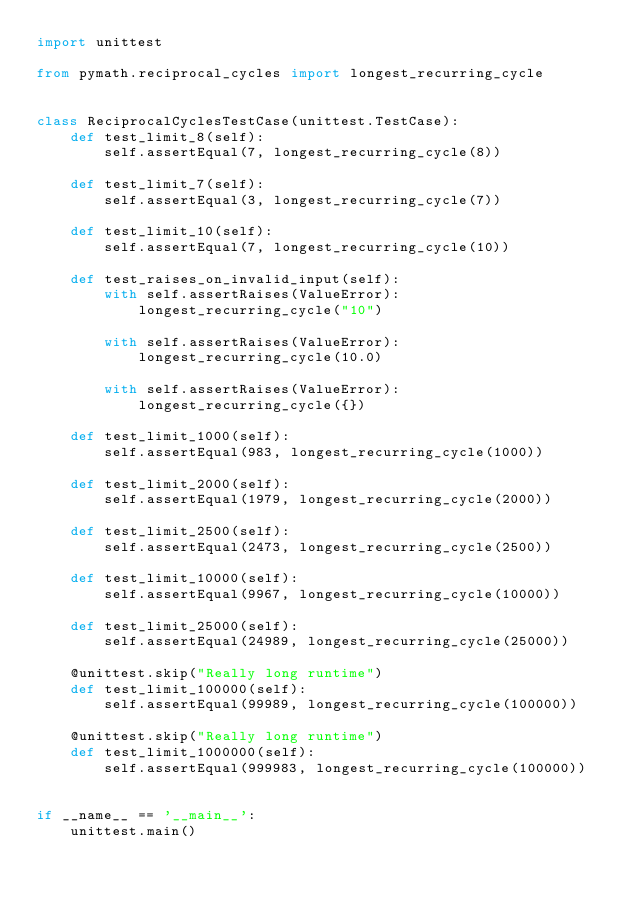Convert code to text. <code><loc_0><loc_0><loc_500><loc_500><_Python_>import unittest

from pymath.reciprocal_cycles import longest_recurring_cycle


class ReciprocalCyclesTestCase(unittest.TestCase):
    def test_limit_8(self):
        self.assertEqual(7, longest_recurring_cycle(8))

    def test_limit_7(self):
        self.assertEqual(3, longest_recurring_cycle(7))

    def test_limit_10(self):
        self.assertEqual(7, longest_recurring_cycle(10))

    def test_raises_on_invalid_input(self):
        with self.assertRaises(ValueError):
            longest_recurring_cycle("10")

        with self.assertRaises(ValueError):
            longest_recurring_cycle(10.0)

        with self.assertRaises(ValueError):
            longest_recurring_cycle({})

    def test_limit_1000(self):
        self.assertEqual(983, longest_recurring_cycle(1000))

    def test_limit_2000(self):
        self.assertEqual(1979, longest_recurring_cycle(2000))

    def test_limit_2500(self):
        self.assertEqual(2473, longest_recurring_cycle(2500))

    def test_limit_10000(self):
        self.assertEqual(9967, longest_recurring_cycle(10000))

    def test_limit_25000(self):
        self.assertEqual(24989, longest_recurring_cycle(25000))

    @unittest.skip("Really long runtime")
    def test_limit_100000(self):
        self.assertEqual(99989, longest_recurring_cycle(100000))

    @unittest.skip("Really long runtime")
    def test_limit_1000000(self):
        self.assertEqual(999983, longest_recurring_cycle(100000))


if __name__ == '__main__':
    unittest.main()
</code> 